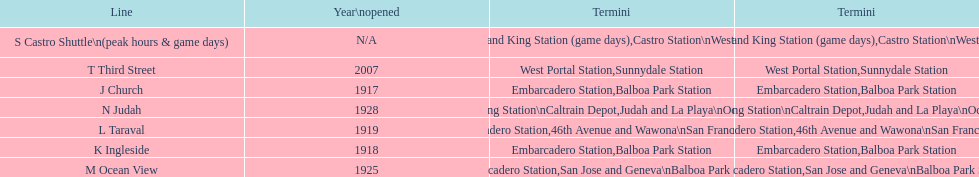On game days, which line do you want to use? S Castro Shuttle. 